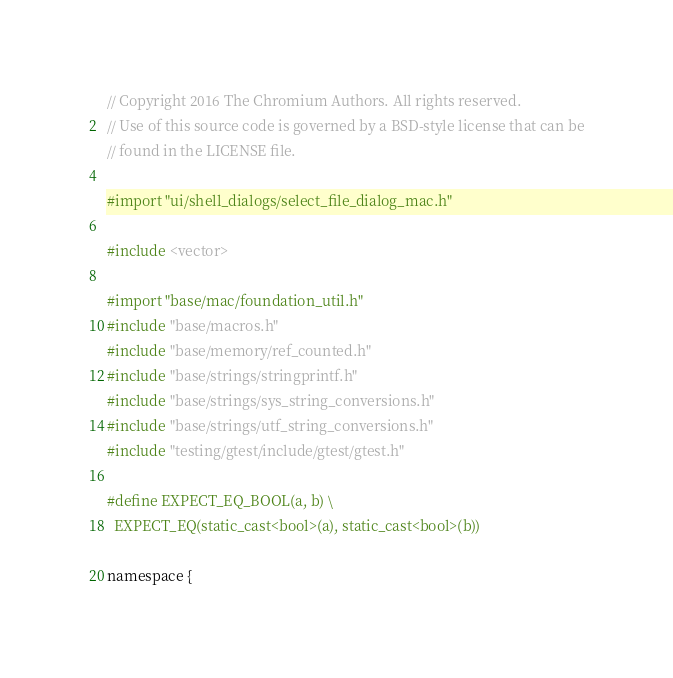<code> <loc_0><loc_0><loc_500><loc_500><_ObjectiveC_>// Copyright 2016 The Chromium Authors. All rights reserved.
// Use of this source code is governed by a BSD-style license that can be
// found in the LICENSE file.

#import "ui/shell_dialogs/select_file_dialog_mac.h"

#include <vector>

#import "base/mac/foundation_util.h"
#include "base/macros.h"
#include "base/memory/ref_counted.h"
#include "base/strings/stringprintf.h"
#include "base/strings/sys_string_conversions.h"
#include "base/strings/utf_string_conversions.h"
#include "testing/gtest/include/gtest/gtest.h"

#define EXPECT_EQ_BOOL(a, b) \
  EXPECT_EQ(static_cast<bool>(a), static_cast<bool>(b))

namespace {</code> 